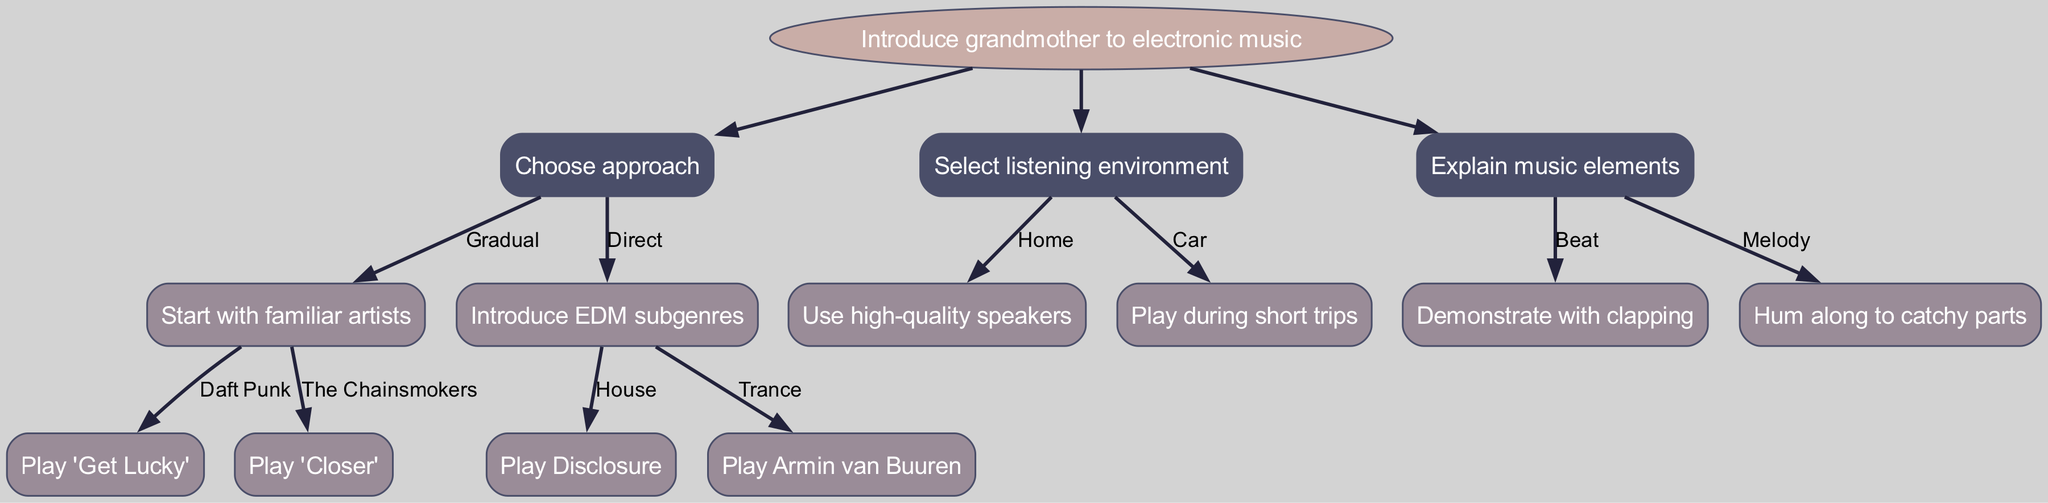What is the root node of the diagram? The root node is indicated at the top of the diagram, labeled "Introduce grandmother to electronic music."
Answer: Introduce grandmother to electronic music How many branches are there from the root node? There are three primary branches emerging from the root node, which are "Choose approach," "Select listening environment," and "Explain music elements."
Answer: 3 What are the two options under "Choose approach"? The diagram shows two options that branch out under "Choose approach": "Gradual" and "Direct."
Answer: Gradual, Direct Which song is suggested the most under "Gradual"? The "Gradual" option branches into two specific artists, with "Play 'Get Lucky'" associated with Daft Punk being the first suggested song.
Answer: Play 'Get Lucky' What would you demonstrate to explain the "Beat"? The diagram specifies that to explain the "Beat," one would demonstrate with clapping, which is a physical activity that represents rhythm.
Answer: Demonstrate with clapping If you choose "Direct," what are the two subgenres introduced? Under the "Direct" approach, there are two EDM subgenres listed: "House" and "Trance."
Answer: House, Trance What is recommended for the listening environment "Car"? According to the diagram, when in a car, it is recommended to "Play during short trips," indicating a preference for brief listening sessions.
Answer: Play during short trips Which artist is associated with "Trance"? The diagram makes an explicit connection where "Armin van Buuren" is noted as the artist associated with the EDM subgenre "Trance."
Answer: Armin van Buuren What is the first option under "Select listening environment"? The first option listed under "Select listening environment" is "Home," indicating an indoor setting for music listening.
Answer: Home 